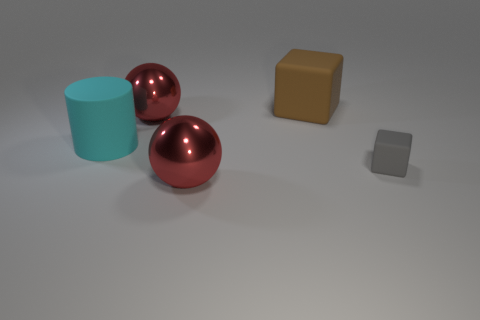Are there any other things that have the same size as the gray matte block?
Your answer should be very brief. No. Are there an equal number of brown blocks that are in front of the rubber cylinder and big brown spheres?
Give a very brief answer. Yes. Is the size of the brown thing the same as the cyan cylinder?
Keep it short and to the point. Yes. What is the size of the rubber thing that is on the left side of the matte block that is behind the cyan rubber thing?
Provide a succinct answer. Large. There is a rubber object that is to the right of the large cyan cylinder and in front of the brown rubber thing; how big is it?
Give a very brief answer. Small. What number of gray blocks are the same size as the cyan matte thing?
Your answer should be compact. 0. How many matte things are either large brown things or large balls?
Give a very brief answer. 1. What is the material of the block that is in front of the large red object that is behind the small gray matte block?
Provide a succinct answer. Rubber. What number of objects are large brown matte cubes or large red shiny things that are in front of the big brown matte cube?
Ensure brevity in your answer.  3. There is a brown thing that is the same material as the tiny gray object; what size is it?
Your answer should be compact. Large. 